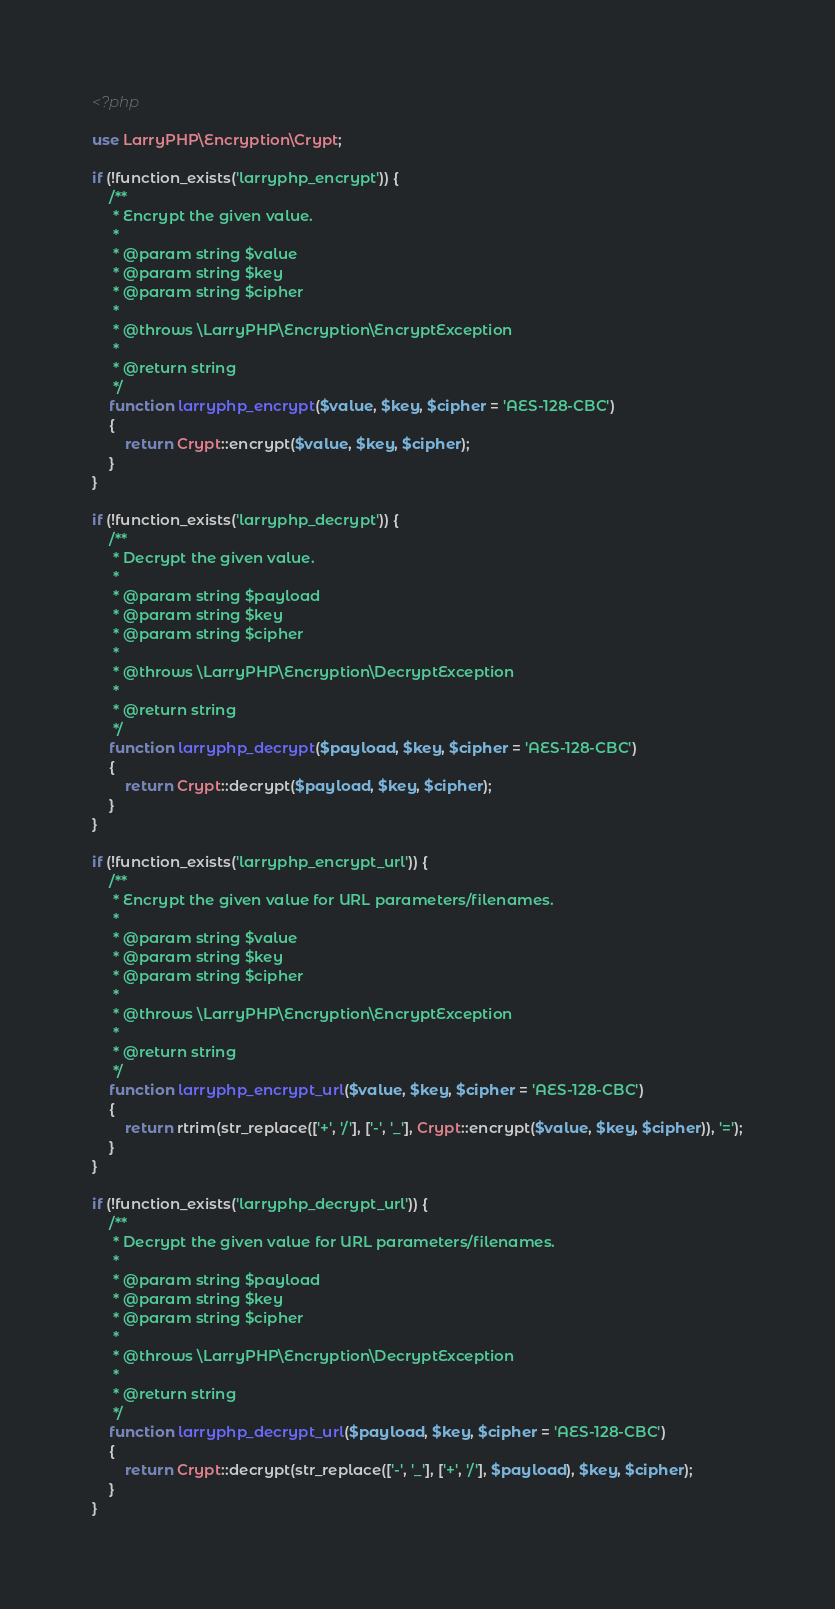<code> <loc_0><loc_0><loc_500><loc_500><_PHP_><?php

use LarryPHP\Encryption\Crypt;

if (!function_exists('larryphp_encrypt')) {
    /**
     * Encrypt the given value.
     *
     * @param string $value
     * @param string $key
     * @param string $cipher
     *
     * @throws \LarryPHP\Encryption\EncryptException
     *
     * @return string
     */
    function larryphp_encrypt($value, $key, $cipher = 'AES-128-CBC')
    {
        return Crypt::encrypt($value, $key, $cipher);
    }
}

if (!function_exists('larryphp_decrypt')) {
    /**
     * Decrypt the given value.
     *
     * @param string $payload
     * @param string $key
     * @param string $cipher
     *
     * @throws \LarryPHP\Encryption\DecryptException
     *
     * @return string
     */
    function larryphp_decrypt($payload, $key, $cipher = 'AES-128-CBC')
    {
        return Crypt::decrypt($payload, $key, $cipher);
    }
}

if (!function_exists('larryphp_encrypt_url')) {
    /**
     * Encrypt the given value for URL parameters/filenames.
     *
     * @param string $value
     * @param string $key
     * @param string $cipher
     *
     * @throws \LarryPHP\Encryption\EncryptException
     *
     * @return string
     */
    function larryphp_encrypt_url($value, $key, $cipher = 'AES-128-CBC')
    {
        return rtrim(str_replace(['+', '/'], ['-', '_'], Crypt::encrypt($value, $key, $cipher)), '=');
    }
}

if (!function_exists('larryphp_decrypt_url')) {
    /**
     * Decrypt the given value for URL parameters/filenames.
     *
     * @param string $payload
     * @param string $key
     * @param string $cipher
     *
     * @throws \LarryPHP\Encryption\DecryptException
     *
     * @return string
     */
    function larryphp_decrypt_url($payload, $key, $cipher = 'AES-128-CBC')
    {
        return Crypt::decrypt(str_replace(['-', '_'], ['+', '/'], $payload), $key, $cipher);
    }
}
</code> 